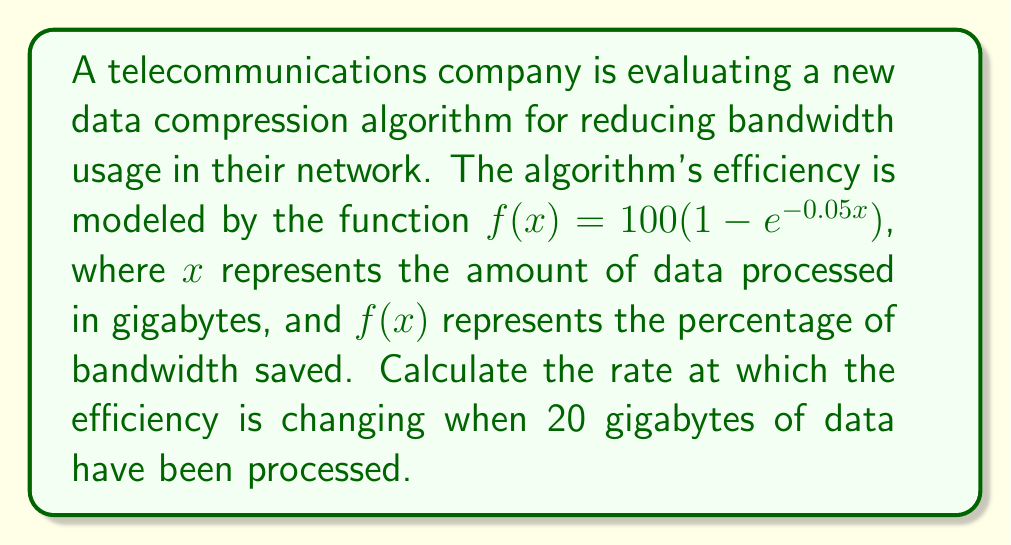Solve this math problem. To solve this problem, we need to find the derivative of the given function and evaluate it at x = 20. This will give us the rate of change of the efficiency at that point.

Step 1: Identify the function
$f(x) = 100(1 - e^{-0.05x})$

Step 2: Calculate the derivative using the chain rule
$$\begin{align}
f'(x) &= 100 \cdot \frac{d}{dx}(1 - e^{-0.05x}) \\
&= 100 \cdot (-1) \cdot \frac{d}{dx}(e^{-0.05x}) \\
&= 100 \cdot (-1) \cdot e^{-0.05x} \cdot (-0.05) \\
&= 5e^{-0.05x}
\end{align}$$

Step 3: Evaluate the derivative at x = 20
$$\begin{align}
f'(20) &= 5e^{-0.05(20)} \\
&= 5e^{-1} \\
&\approx 1.839
\end{align}$$

This result means that when 20 gigabytes of data have been processed, the efficiency of the compression algorithm is increasing at a rate of approximately 1.839 percentage points per gigabyte.
Answer: $5e^{-1}$ or approximately 1.839 percentage points per gigabyte 